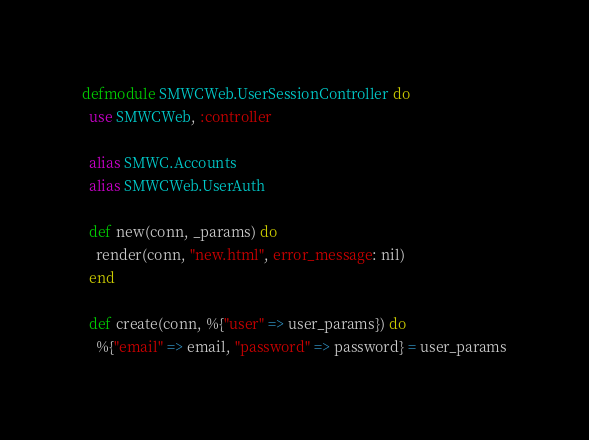<code> <loc_0><loc_0><loc_500><loc_500><_Elixir_>defmodule SMWCWeb.UserSessionController do
  use SMWCWeb, :controller

  alias SMWC.Accounts
  alias SMWCWeb.UserAuth

  def new(conn, _params) do
    render(conn, "new.html", error_message: nil)
  end

  def create(conn, %{"user" => user_params}) do
    %{"email" => email, "password" => password} = user_params
</code> 